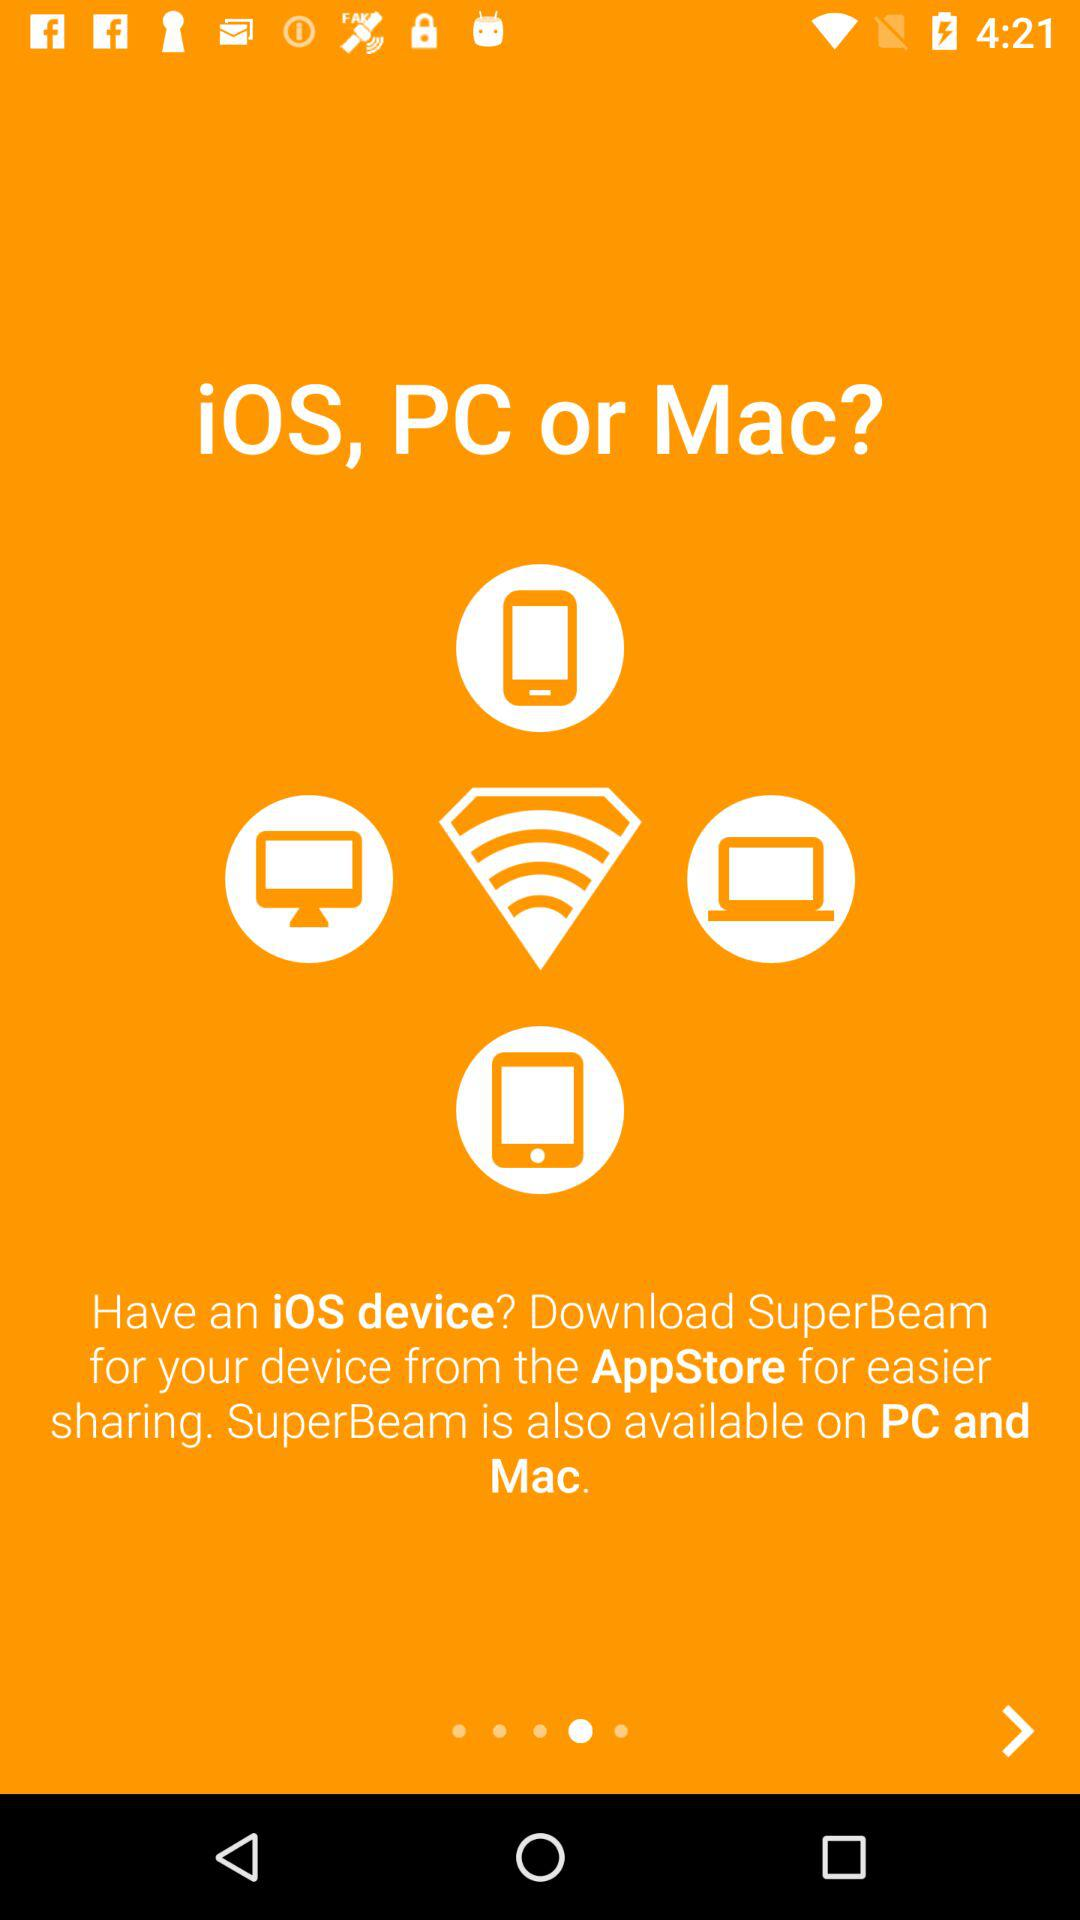What is the name of the application? The name of the application is "SuperBeam". 